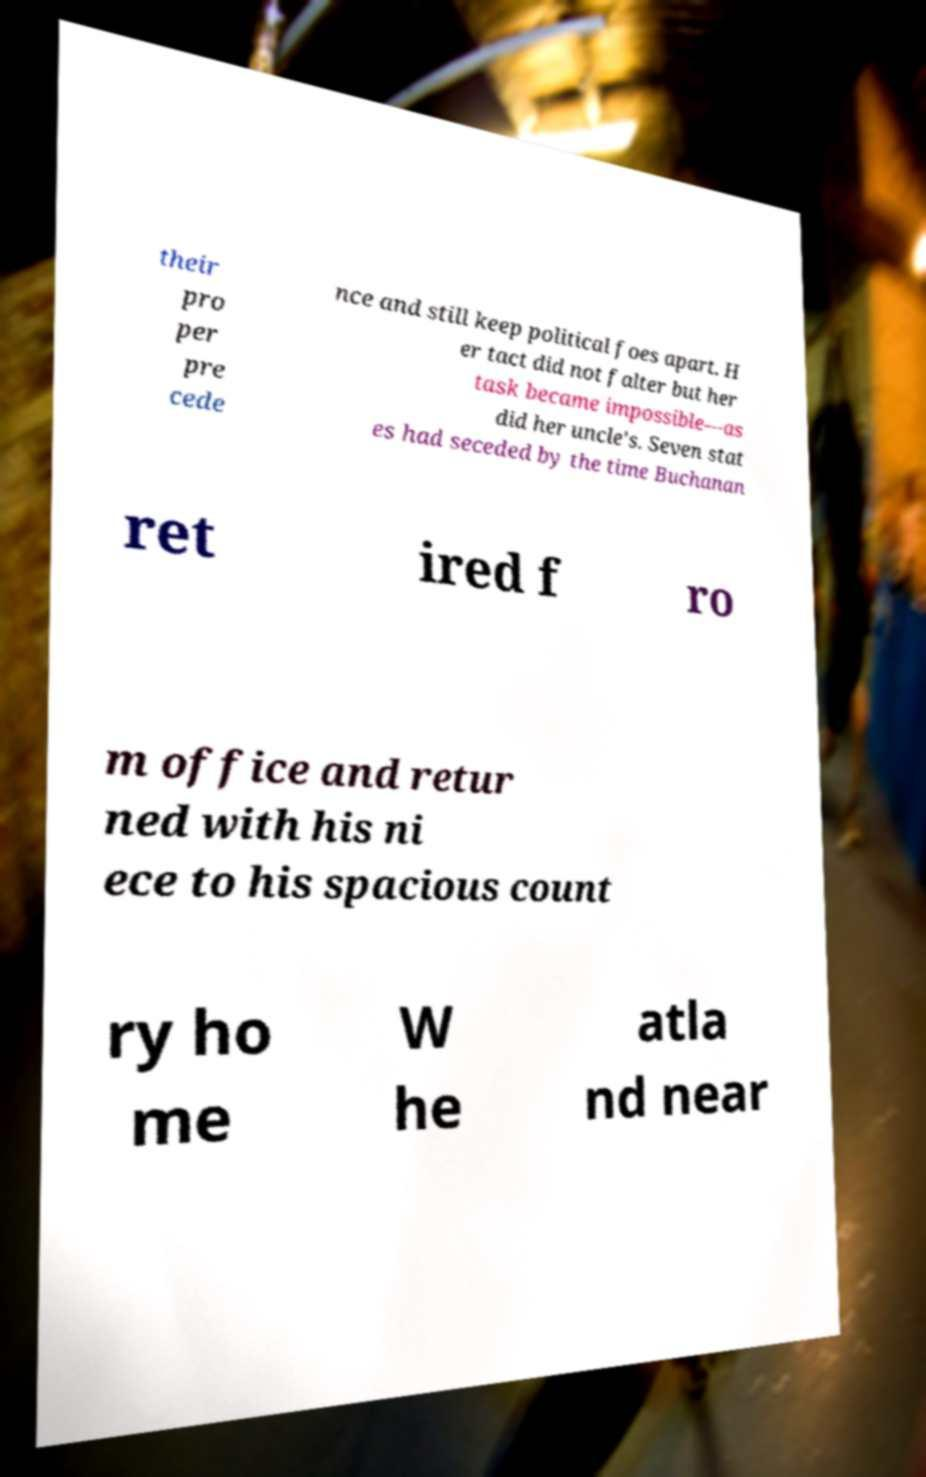There's text embedded in this image that I need extracted. Can you transcribe it verbatim? their pro per pre cede nce and still keep political foes apart. H er tact did not falter but her task became impossible—as did her uncle's. Seven stat es had seceded by the time Buchanan ret ired f ro m office and retur ned with his ni ece to his spacious count ry ho me W he atla nd near 